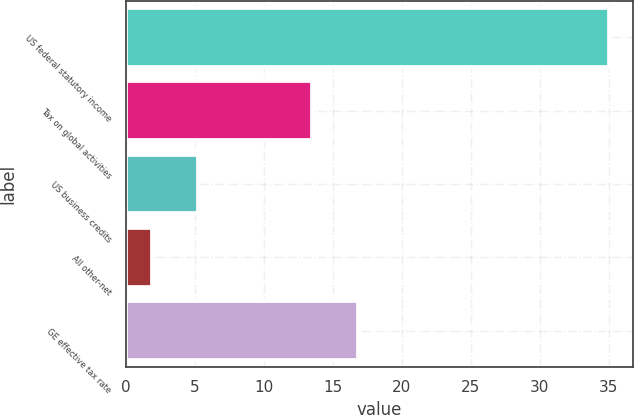<chart> <loc_0><loc_0><loc_500><loc_500><bar_chart><fcel>US federal statutory income<fcel>Tax on global activities<fcel>US business credits<fcel>All other-net<fcel>GE effective tax rate<nl><fcel>35<fcel>13.5<fcel>5.21<fcel>1.9<fcel>16.81<nl></chart> 